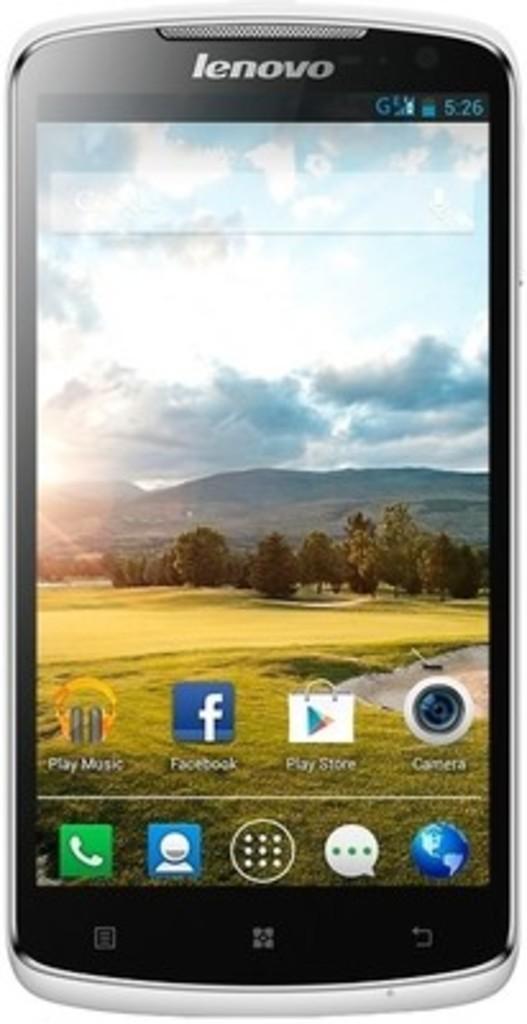What brand is the phone?
Give a very brief answer. Lenovo. What is the time on the phone?
Your response must be concise. 5:26. 